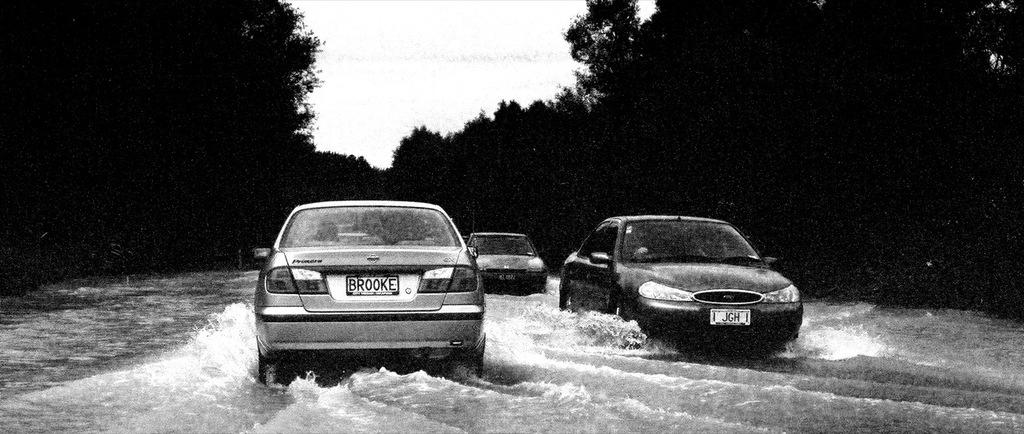How many cars can be seen in the image? There are three cars in the image. What else is present in the image besides the cars? There is water flowing, trees, and the sky visible in the image. What type of drug is being used by the giants in the image? There are no giants present in the image, and therefore no drug use can be observed. 